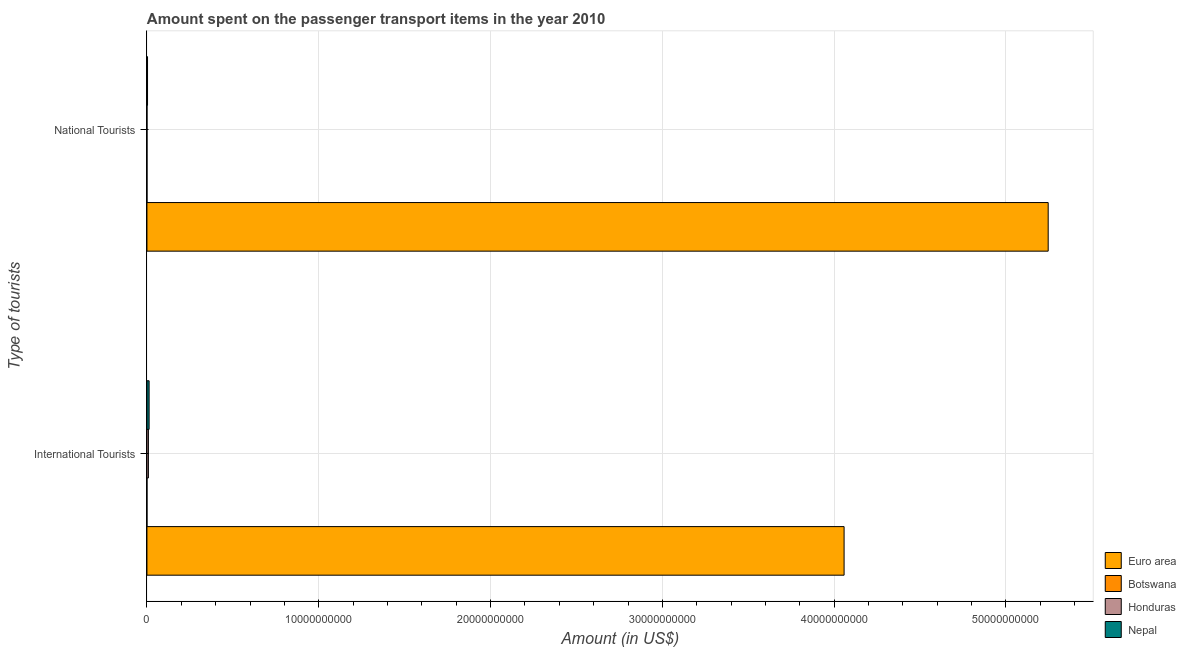How many groups of bars are there?
Provide a succinct answer. 2. Are the number of bars per tick equal to the number of legend labels?
Make the answer very short. Yes. Are the number of bars on each tick of the Y-axis equal?
Offer a very short reply. Yes. What is the label of the 2nd group of bars from the top?
Offer a very short reply. International Tourists. What is the amount spent on transport items of national tourists in Nepal?
Give a very brief answer. 3.40e+07. Across all countries, what is the maximum amount spent on transport items of national tourists?
Ensure brevity in your answer.  5.25e+1. Across all countries, what is the minimum amount spent on transport items of international tourists?
Give a very brief answer. 5.00e+05. In which country was the amount spent on transport items of international tourists minimum?
Provide a short and direct response. Botswana. What is the total amount spent on transport items of international tourists in the graph?
Ensure brevity in your answer.  4.08e+1. What is the difference between the amount spent on transport items of international tourists in Botswana and that in Euro area?
Your answer should be very brief. -4.06e+1. What is the difference between the amount spent on transport items of international tourists in Euro area and the amount spent on transport items of national tourists in Honduras?
Provide a short and direct response. 4.06e+1. What is the average amount spent on transport items of international tourists per country?
Offer a very short reply. 1.02e+1. What is the difference between the amount spent on transport items of international tourists and amount spent on transport items of national tourists in Botswana?
Ensure brevity in your answer.  -1.50e+06. What is the ratio of the amount spent on transport items of national tourists in Euro area to that in Honduras?
Your answer should be very brief. 3.09e+04. Is the amount spent on transport items of national tourists in Botswana less than that in Euro area?
Keep it short and to the point. Yes. In how many countries, is the amount spent on transport items of international tourists greater than the average amount spent on transport items of international tourists taken over all countries?
Give a very brief answer. 1. What does the 2nd bar from the top in National Tourists represents?
Give a very brief answer. Honduras. What does the 3rd bar from the bottom in National Tourists represents?
Provide a short and direct response. Honduras. How many countries are there in the graph?
Keep it short and to the point. 4. What is the difference between two consecutive major ticks on the X-axis?
Your answer should be very brief. 1.00e+1. Does the graph contain any zero values?
Your answer should be very brief. No. Where does the legend appear in the graph?
Keep it short and to the point. Bottom right. What is the title of the graph?
Provide a short and direct response. Amount spent on the passenger transport items in the year 2010. Does "Serbia" appear as one of the legend labels in the graph?
Give a very brief answer. No. What is the label or title of the X-axis?
Provide a short and direct response. Amount (in US$). What is the label or title of the Y-axis?
Your answer should be very brief. Type of tourists. What is the Amount (in US$) of Euro area in International Tourists?
Provide a succinct answer. 4.06e+1. What is the Amount (in US$) in Honduras in International Tourists?
Provide a short and direct response. 8.50e+07. What is the Amount (in US$) of Nepal in International Tourists?
Offer a terse response. 1.26e+08. What is the Amount (in US$) in Euro area in National Tourists?
Provide a short and direct response. 5.25e+1. What is the Amount (in US$) of Honduras in National Tourists?
Provide a succinct answer. 1.70e+06. What is the Amount (in US$) in Nepal in National Tourists?
Keep it short and to the point. 3.40e+07. Across all Type of tourists, what is the maximum Amount (in US$) in Euro area?
Offer a terse response. 5.25e+1. Across all Type of tourists, what is the maximum Amount (in US$) of Botswana?
Offer a very short reply. 2.00e+06. Across all Type of tourists, what is the maximum Amount (in US$) in Honduras?
Keep it short and to the point. 8.50e+07. Across all Type of tourists, what is the maximum Amount (in US$) in Nepal?
Provide a succinct answer. 1.26e+08. Across all Type of tourists, what is the minimum Amount (in US$) of Euro area?
Your answer should be very brief. 4.06e+1. Across all Type of tourists, what is the minimum Amount (in US$) in Botswana?
Your response must be concise. 5.00e+05. Across all Type of tourists, what is the minimum Amount (in US$) in Honduras?
Provide a short and direct response. 1.70e+06. Across all Type of tourists, what is the minimum Amount (in US$) of Nepal?
Your answer should be compact. 3.40e+07. What is the total Amount (in US$) of Euro area in the graph?
Keep it short and to the point. 9.30e+1. What is the total Amount (in US$) in Botswana in the graph?
Give a very brief answer. 2.50e+06. What is the total Amount (in US$) in Honduras in the graph?
Your answer should be compact. 8.67e+07. What is the total Amount (in US$) in Nepal in the graph?
Your answer should be very brief. 1.60e+08. What is the difference between the Amount (in US$) in Euro area in International Tourists and that in National Tourists?
Give a very brief answer. -1.19e+1. What is the difference between the Amount (in US$) in Botswana in International Tourists and that in National Tourists?
Make the answer very short. -1.50e+06. What is the difference between the Amount (in US$) of Honduras in International Tourists and that in National Tourists?
Provide a short and direct response. 8.33e+07. What is the difference between the Amount (in US$) of Nepal in International Tourists and that in National Tourists?
Your answer should be very brief. 9.20e+07. What is the difference between the Amount (in US$) of Euro area in International Tourists and the Amount (in US$) of Botswana in National Tourists?
Ensure brevity in your answer.  4.06e+1. What is the difference between the Amount (in US$) of Euro area in International Tourists and the Amount (in US$) of Honduras in National Tourists?
Provide a short and direct response. 4.06e+1. What is the difference between the Amount (in US$) in Euro area in International Tourists and the Amount (in US$) in Nepal in National Tourists?
Your answer should be compact. 4.05e+1. What is the difference between the Amount (in US$) in Botswana in International Tourists and the Amount (in US$) in Honduras in National Tourists?
Make the answer very short. -1.20e+06. What is the difference between the Amount (in US$) of Botswana in International Tourists and the Amount (in US$) of Nepal in National Tourists?
Give a very brief answer. -3.35e+07. What is the difference between the Amount (in US$) of Honduras in International Tourists and the Amount (in US$) of Nepal in National Tourists?
Provide a short and direct response. 5.10e+07. What is the average Amount (in US$) of Euro area per Type of tourists?
Your answer should be compact. 4.65e+1. What is the average Amount (in US$) of Botswana per Type of tourists?
Give a very brief answer. 1.25e+06. What is the average Amount (in US$) in Honduras per Type of tourists?
Ensure brevity in your answer.  4.34e+07. What is the average Amount (in US$) in Nepal per Type of tourists?
Provide a short and direct response. 8.00e+07. What is the difference between the Amount (in US$) in Euro area and Amount (in US$) in Botswana in International Tourists?
Provide a short and direct response. 4.06e+1. What is the difference between the Amount (in US$) of Euro area and Amount (in US$) of Honduras in International Tourists?
Your answer should be very brief. 4.05e+1. What is the difference between the Amount (in US$) of Euro area and Amount (in US$) of Nepal in International Tourists?
Your answer should be very brief. 4.05e+1. What is the difference between the Amount (in US$) of Botswana and Amount (in US$) of Honduras in International Tourists?
Provide a short and direct response. -8.45e+07. What is the difference between the Amount (in US$) in Botswana and Amount (in US$) in Nepal in International Tourists?
Your response must be concise. -1.26e+08. What is the difference between the Amount (in US$) of Honduras and Amount (in US$) of Nepal in International Tourists?
Your answer should be compact. -4.10e+07. What is the difference between the Amount (in US$) of Euro area and Amount (in US$) of Botswana in National Tourists?
Provide a succinct answer. 5.25e+1. What is the difference between the Amount (in US$) in Euro area and Amount (in US$) in Honduras in National Tourists?
Ensure brevity in your answer.  5.25e+1. What is the difference between the Amount (in US$) of Euro area and Amount (in US$) of Nepal in National Tourists?
Make the answer very short. 5.24e+1. What is the difference between the Amount (in US$) of Botswana and Amount (in US$) of Honduras in National Tourists?
Give a very brief answer. 3.00e+05. What is the difference between the Amount (in US$) in Botswana and Amount (in US$) in Nepal in National Tourists?
Give a very brief answer. -3.20e+07. What is the difference between the Amount (in US$) of Honduras and Amount (in US$) of Nepal in National Tourists?
Keep it short and to the point. -3.23e+07. What is the ratio of the Amount (in US$) of Euro area in International Tourists to that in National Tourists?
Provide a short and direct response. 0.77. What is the ratio of the Amount (in US$) in Honduras in International Tourists to that in National Tourists?
Offer a terse response. 50. What is the ratio of the Amount (in US$) in Nepal in International Tourists to that in National Tourists?
Give a very brief answer. 3.71. What is the difference between the highest and the second highest Amount (in US$) in Euro area?
Offer a very short reply. 1.19e+1. What is the difference between the highest and the second highest Amount (in US$) of Botswana?
Provide a succinct answer. 1.50e+06. What is the difference between the highest and the second highest Amount (in US$) in Honduras?
Offer a very short reply. 8.33e+07. What is the difference between the highest and the second highest Amount (in US$) in Nepal?
Your answer should be very brief. 9.20e+07. What is the difference between the highest and the lowest Amount (in US$) of Euro area?
Your answer should be very brief. 1.19e+1. What is the difference between the highest and the lowest Amount (in US$) in Botswana?
Your answer should be very brief. 1.50e+06. What is the difference between the highest and the lowest Amount (in US$) of Honduras?
Your response must be concise. 8.33e+07. What is the difference between the highest and the lowest Amount (in US$) in Nepal?
Provide a short and direct response. 9.20e+07. 